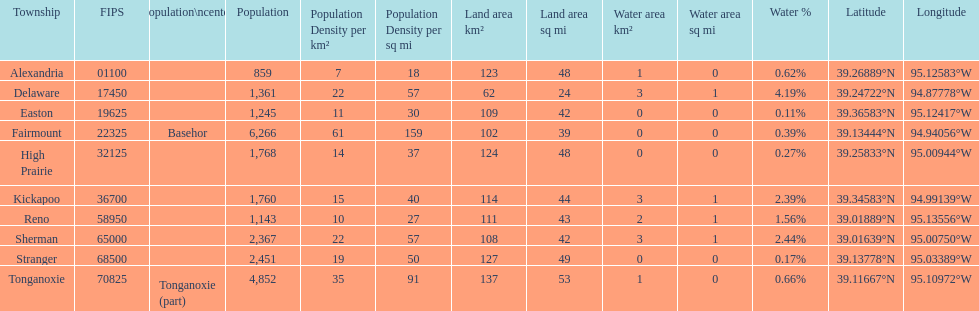Which township has the least land area? Delaware. 